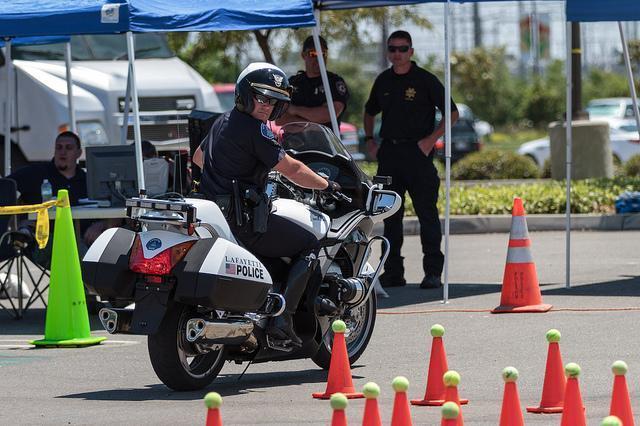How many people are there?
Give a very brief answer. 4. 